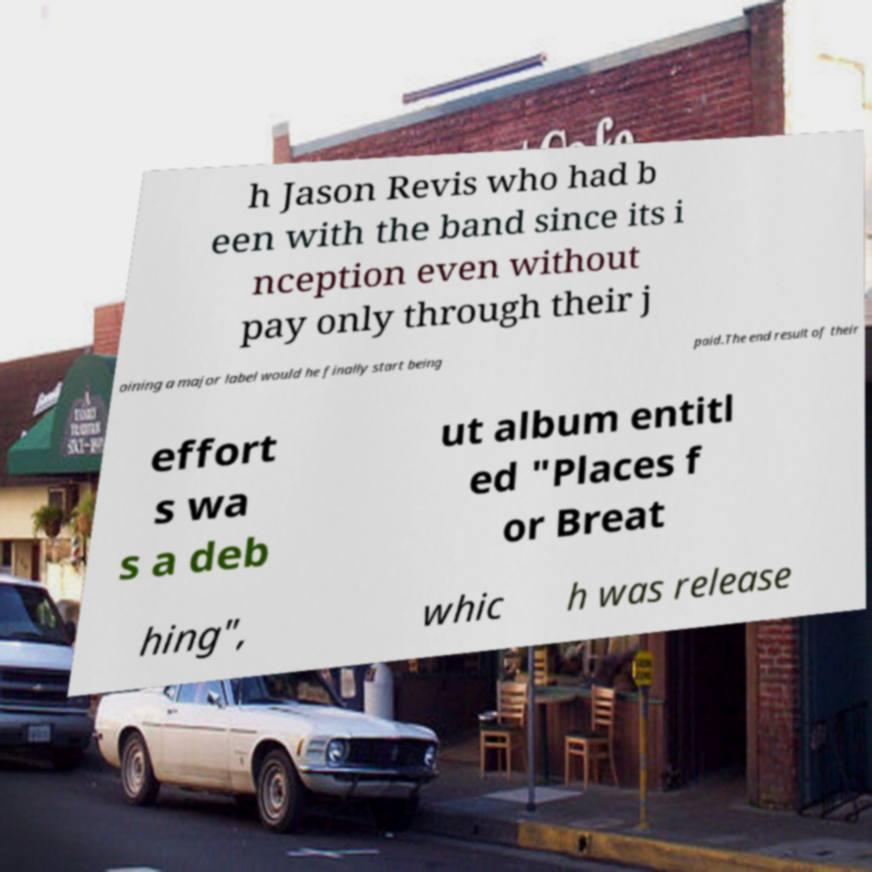I need the written content from this picture converted into text. Can you do that? h Jason Revis who had b een with the band since its i nception even without pay only through their j oining a major label would he finally start being paid.The end result of their effort s wa s a deb ut album entitl ed "Places f or Breat hing", whic h was release 